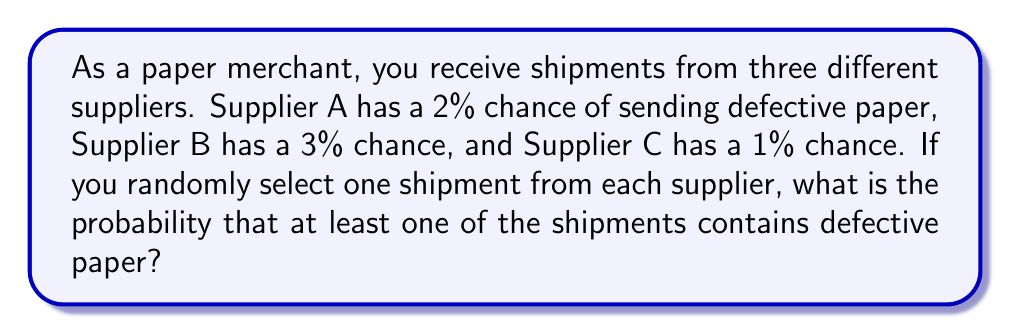Can you answer this question? To solve this problem, we'll use the complement rule of probability. Instead of calculating the probability of at least one defective shipment, we'll calculate the probability of no defective shipments and subtract it from 1.

Let's break it down step-by-step:

1. Probability of receiving a non-defective shipment from each supplier:
   Supplier A: $1 - 0.02 = 0.98$
   Supplier B: $1 - 0.03 = 0.97$
   Supplier C: $1 - 0.01 = 0.99$

2. Probability of all three shipments being non-defective:
   $P(\text{all non-defective}) = 0.98 \times 0.97 \times 0.99 = 0.941094$

3. Probability of at least one defective shipment:
   $P(\text{at least one defective}) = 1 - P(\text{all non-defective})$
   $= 1 - 0.941094 = 0.058906$

Therefore, the probability of receiving at least one defective shipment is approximately 0.058906 or 5.8906%.
Answer: The probability of receiving at least one defective paper shipment is $0.058906$ or $5.8906\%$. 